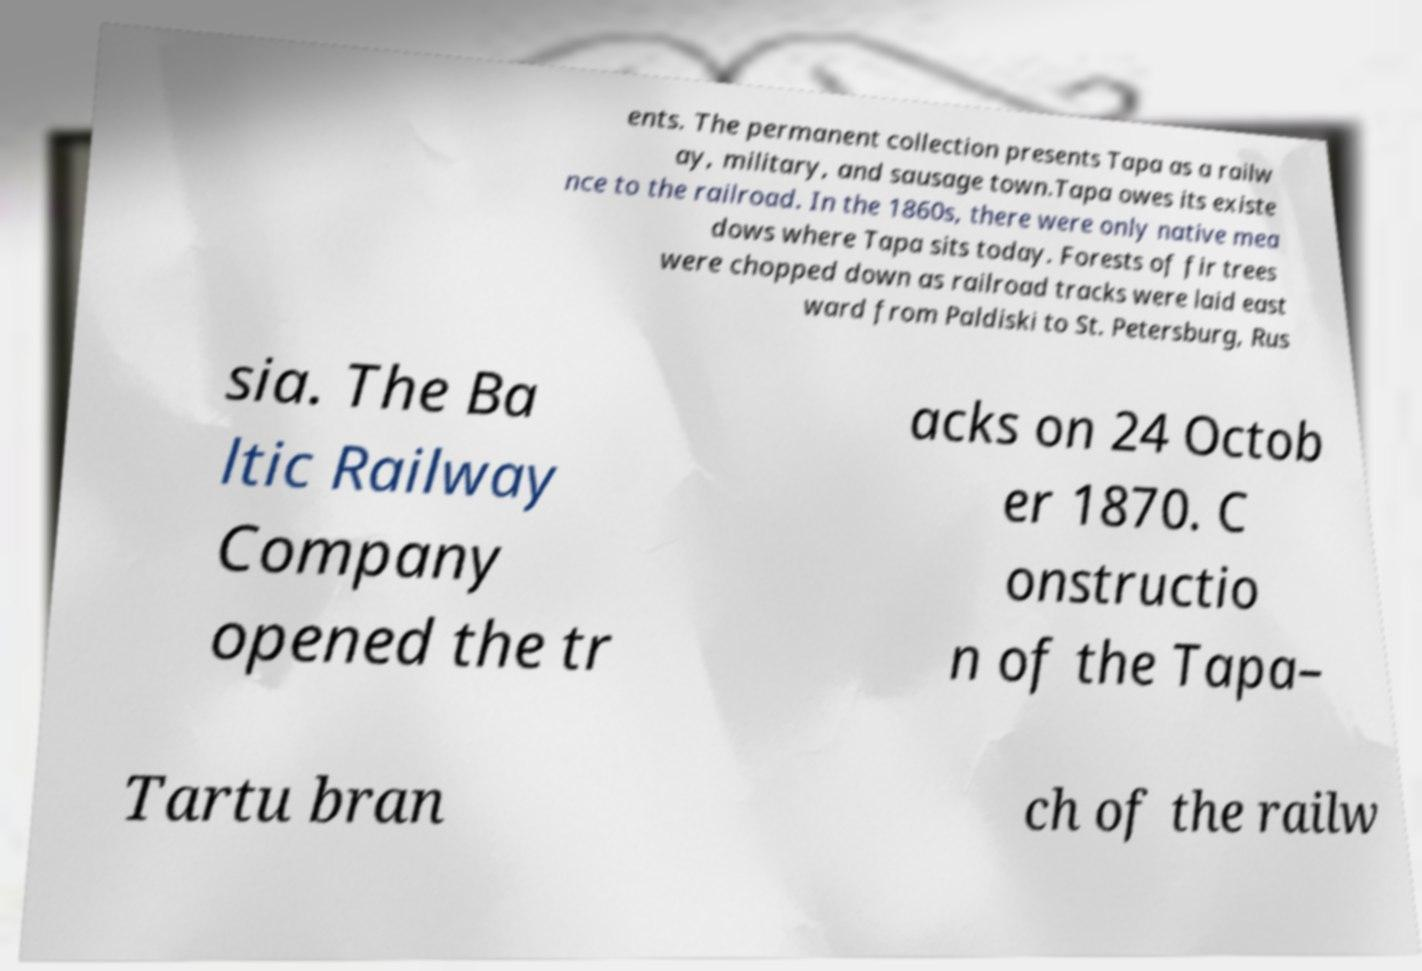There's text embedded in this image that I need extracted. Can you transcribe it verbatim? ents. The permanent collection presents Tapa as a railw ay, military, and sausage town.Tapa owes its existe nce to the railroad. In the 1860s, there were only native mea dows where Tapa sits today. Forests of fir trees were chopped down as railroad tracks were laid east ward from Paldiski to St. Petersburg, Rus sia. The Ba ltic Railway Company opened the tr acks on 24 Octob er 1870. C onstructio n of the Tapa– Tartu bran ch of the railw 